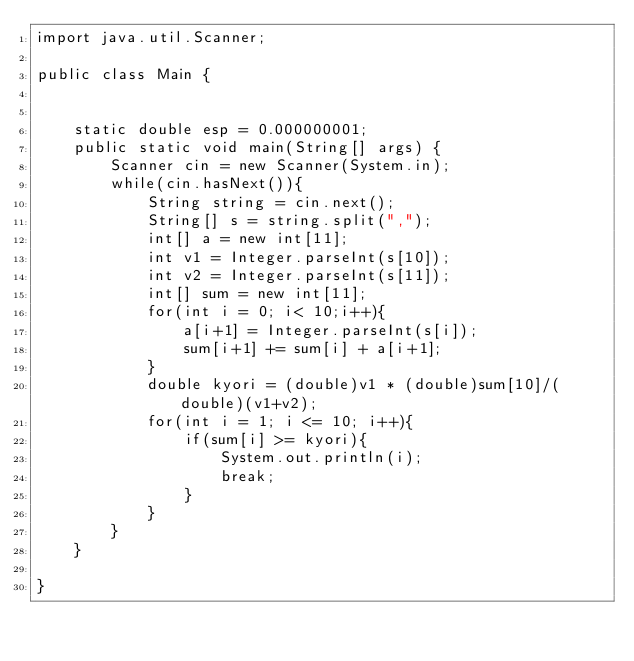<code> <loc_0><loc_0><loc_500><loc_500><_Java_>import java.util.Scanner;

public class Main {


	static double esp = 0.000000001;
	public static void main(String[] args) {
		Scanner cin = new Scanner(System.in);
		while(cin.hasNext()){
			String string = cin.next();
			String[] s = string.split(",");
			int[] a = new int[11];
			int v1 = Integer.parseInt(s[10]);
			int v2 = Integer.parseInt(s[11]);
			int[] sum = new int[11]; 
			for(int i = 0; i< 10;i++){
				a[i+1] = Integer.parseInt(s[i]);
				sum[i+1] += sum[i] + a[i+1];
			}
			double kyori = (double)v1 * (double)sum[10]/(double)(v1+v2);
			for(int i = 1; i <= 10; i++){
				if(sum[i] >= kyori){
					System.out.println(i);
					break;
				}
			}
		}
	}

}</code> 